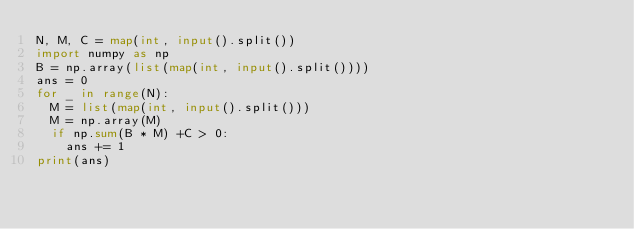<code> <loc_0><loc_0><loc_500><loc_500><_Python_>N, M, C = map(int, input().split())
import numpy as np
B = np.array(list(map(int, input().split())))
ans = 0
for _ in range(N):
  M = list(map(int, input().split()))
  M = np.array(M)
  if np.sum(B * M) +C > 0:
    ans += 1
print(ans)</code> 